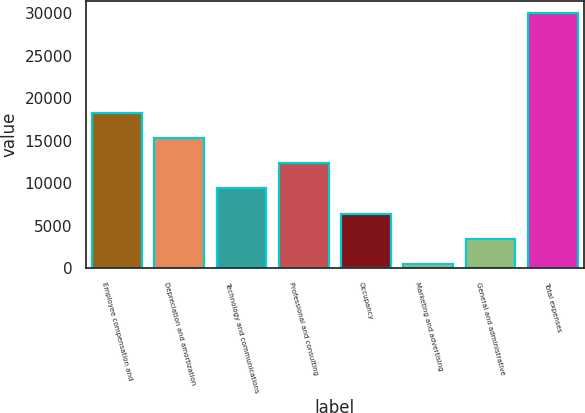Convert chart to OTSL. <chart><loc_0><loc_0><loc_500><loc_500><bar_chart><fcel>Employee compensation and<fcel>Depreciation and amortization<fcel>Technology and communications<fcel>Professional and consulting<fcel>Occupancy<fcel>Marketing and advertising<fcel>General and administrative<fcel>Total expenses<nl><fcel>18204.6<fcel>15260<fcel>9370.8<fcel>12315.4<fcel>6426.2<fcel>537<fcel>3481.6<fcel>29983<nl></chart> 